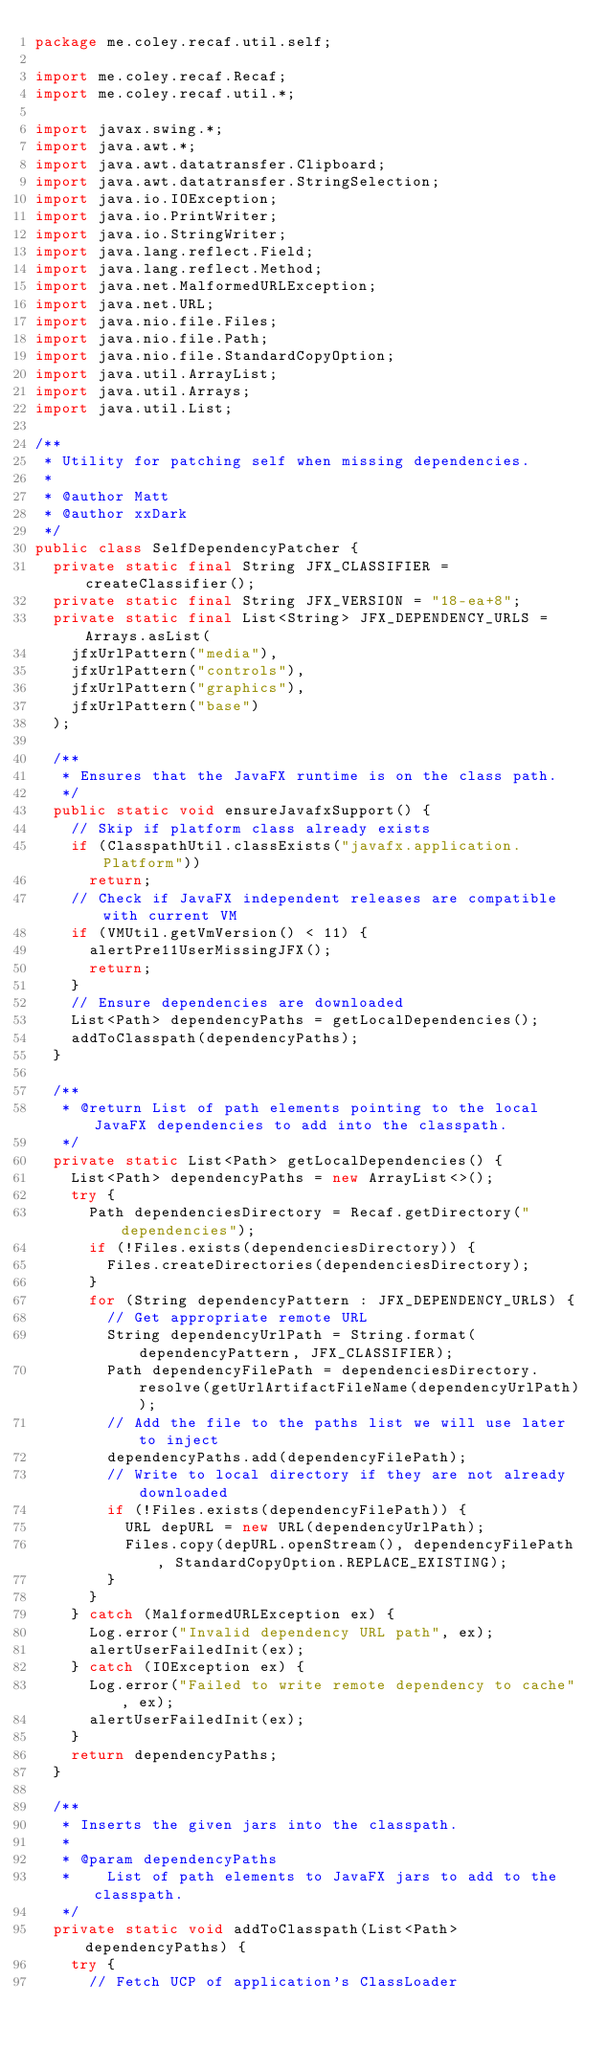Convert code to text. <code><loc_0><loc_0><loc_500><loc_500><_Java_>package me.coley.recaf.util.self;

import me.coley.recaf.Recaf;
import me.coley.recaf.util.*;

import javax.swing.*;
import java.awt.*;
import java.awt.datatransfer.Clipboard;
import java.awt.datatransfer.StringSelection;
import java.io.IOException;
import java.io.PrintWriter;
import java.io.StringWriter;
import java.lang.reflect.Field;
import java.lang.reflect.Method;
import java.net.MalformedURLException;
import java.net.URL;
import java.nio.file.Files;
import java.nio.file.Path;
import java.nio.file.StandardCopyOption;
import java.util.ArrayList;
import java.util.Arrays;
import java.util.List;

/**
 * Utility for patching self when missing dependencies.
 *
 * @author Matt
 * @author xxDark
 */
public class SelfDependencyPatcher {
	private static final String JFX_CLASSIFIER = createClassifier();
	private static final String JFX_VERSION = "18-ea+8";
	private static final List<String> JFX_DEPENDENCY_URLS = Arrays.asList(
		jfxUrlPattern("media"),
		jfxUrlPattern("controls"),
		jfxUrlPattern("graphics"),
		jfxUrlPattern("base")
	);

	/**
	 * Ensures that the JavaFX runtime is on the class path.
	 */
	public static void ensureJavafxSupport() {
		// Skip if platform class already exists
		if (ClasspathUtil.classExists("javafx.application.Platform"))
			return;
		// Check if JavaFX independent releases are compatible with current VM
		if (VMUtil.getVmVersion() < 11) {
			alertPre11UserMissingJFX();
			return;
		}
		// Ensure dependencies are downloaded
		List<Path> dependencyPaths = getLocalDependencies();
		addToClasspath(dependencyPaths);
	}

	/**
	 * @return List of path elements pointing to the local JavaFX dependencies to add into the classpath.
	 */
	private static List<Path> getLocalDependencies() {
		List<Path> dependencyPaths = new ArrayList<>();
		try {
			Path dependenciesDirectory = Recaf.getDirectory("dependencies");
			if (!Files.exists(dependenciesDirectory)) {
				Files.createDirectories(dependenciesDirectory);
			}
			for (String dependencyPattern : JFX_DEPENDENCY_URLS) {
				// Get appropriate remote URL
				String dependencyUrlPath = String.format(dependencyPattern, JFX_CLASSIFIER);
				Path dependencyFilePath = dependenciesDirectory.resolve(getUrlArtifactFileName(dependencyUrlPath));
				// Add the file to the paths list we will use later to inject
				dependencyPaths.add(dependencyFilePath);
				// Write to local directory if they are not already downloaded
				if (!Files.exists(dependencyFilePath)) {
					URL depURL = new URL(dependencyUrlPath);
					Files.copy(depURL.openStream(), dependencyFilePath, StandardCopyOption.REPLACE_EXISTING);
				}
			}
		} catch (MalformedURLException ex) {
			Log.error("Invalid dependency URL path", ex);
			alertUserFailedInit(ex);
		} catch (IOException ex) {
			Log.error("Failed to write remote dependency to cache", ex);
			alertUserFailedInit(ex);
		}
		return dependencyPaths;
	}

	/**
	 * Inserts the given jars into the classpath.
	 *
	 * @param dependencyPaths
	 * 		List of path elements to JavaFX jars to add to the classpath.
	 */
	private static void addToClasspath(List<Path> dependencyPaths) {
		try {
			// Fetch UCP of application's ClassLoader</code> 